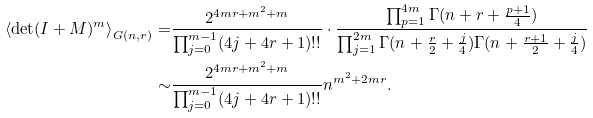Convert formula to latex. <formula><loc_0><loc_0><loc_500><loc_500>\left \langle \det ( I + M ) ^ { m } \right \rangle _ { G ( n , r ) } = & \frac { 2 ^ { 4 m r + m ^ { 2 } + m } } { \prod _ { j = 0 } ^ { m - 1 } ( 4 j + 4 r + 1 ) ! ! } \cdot \frac { \prod _ { p = 1 } ^ { 4 m } \Gamma ( n + r + \frac { p + 1 } { 4 } ) } { \prod _ { j = 1 } ^ { 2 m } \Gamma ( n + \frac { r } { 2 } + \frac { j } { 4 } ) \Gamma ( n + \frac { r + 1 } { 2 } + \frac { j } { 4 } ) } \\ \sim & \frac { 2 ^ { 4 m r + m ^ { 2 } + m } } { \prod _ { j = 0 } ^ { m - 1 } ( 4 j + 4 r + 1 ) ! ! } n ^ { m ^ { 2 } + 2 m r } .</formula> 